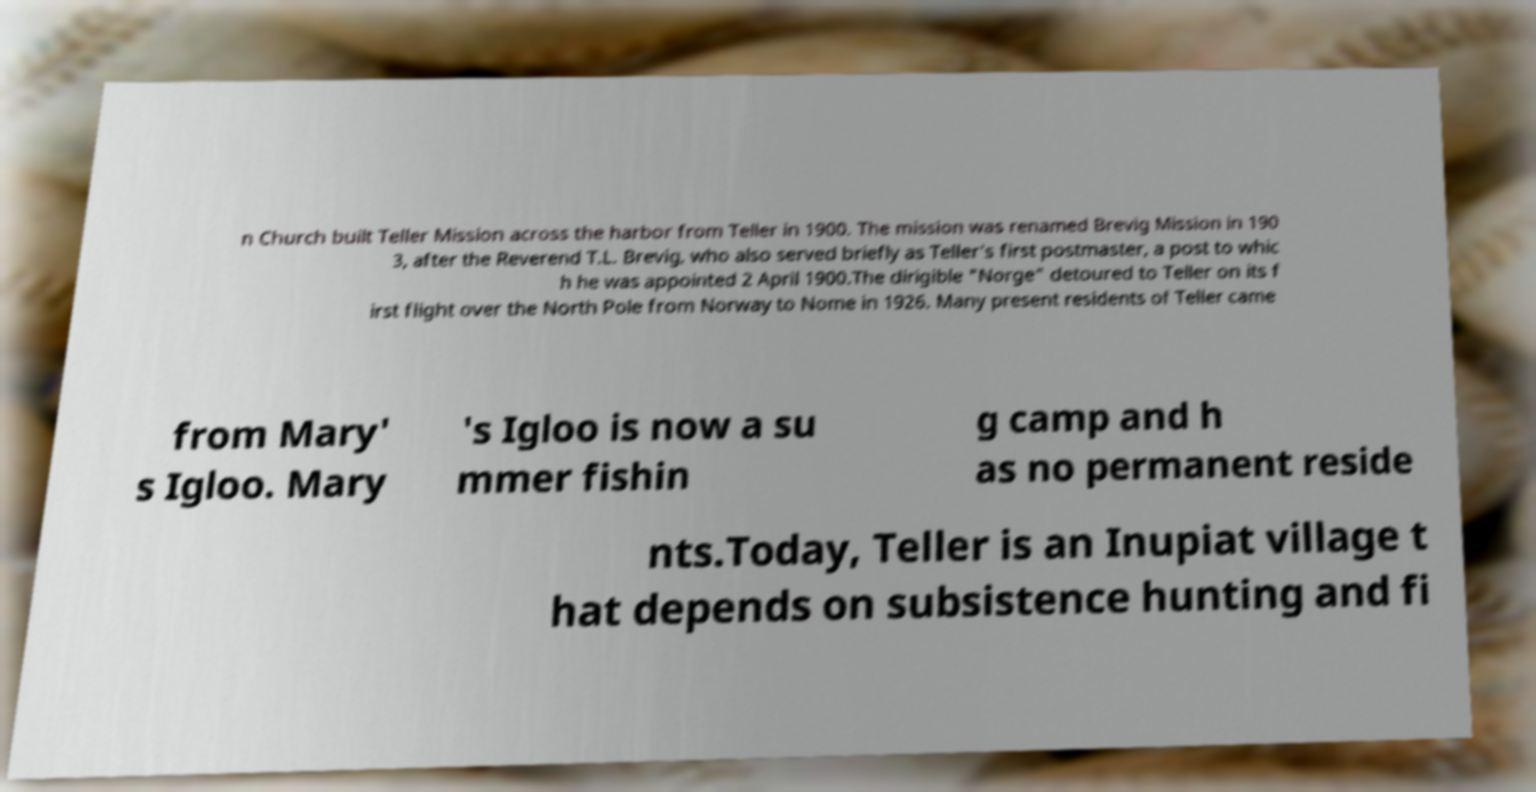There's text embedded in this image that I need extracted. Can you transcribe it verbatim? n Church built Teller Mission across the harbor from Teller in 1900. The mission was renamed Brevig Mission in 190 3, after the Reverend T.L. Brevig, who also served briefly as Teller's first postmaster, a post to whic h he was appointed 2 April 1900.The dirigible "Norge" detoured to Teller on its f irst flight over the North Pole from Norway to Nome in 1926. Many present residents of Teller came from Mary' s Igloo. Mary 's Igloo is now a su mmer fishin g camp and h as no permanent reside nts.Today, Teller is an Inupiat village t hat depends on subsistence hunting and fi 